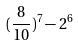<formula> <loc_0><loc_0><loc_500><loc_500>( \frac { 8 } { 1 0 } ) ^ { 7 } - 2 ^ { 6 }</formula> 